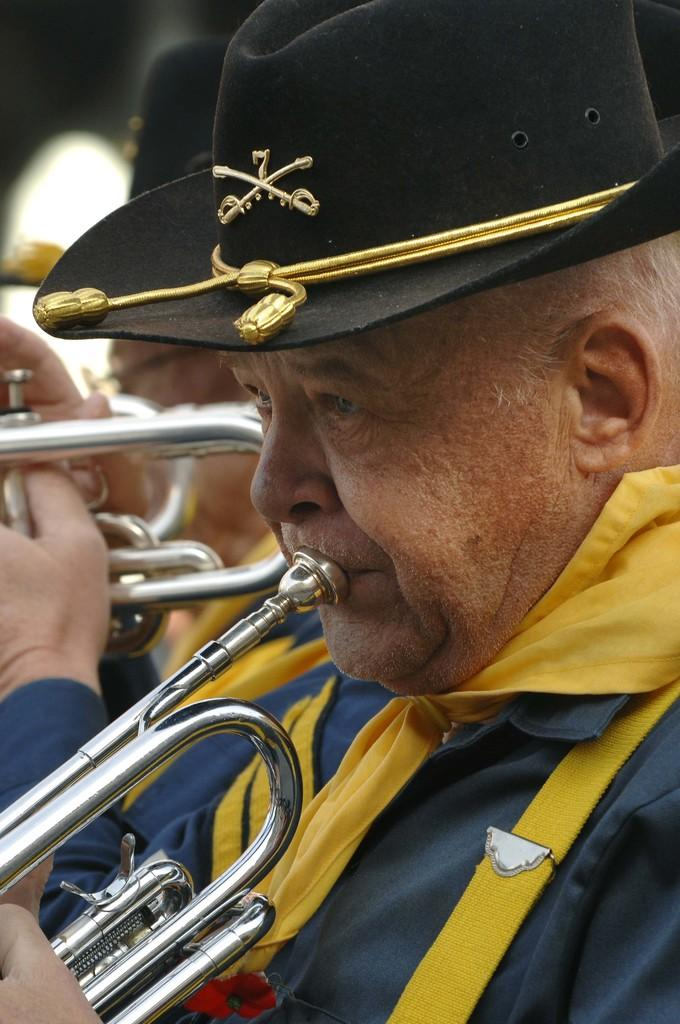Who or what is present in the image? There are people in the image. What are the people wearing on their upper bodies? The people are wearing blue color shirts. What are the people wearing on their heads? The people are wearing black color caps on their heads. What are the people doing in the image? The people are playing musical instruments. What type of powder is being used by the people in the image? There is no powder present in the image; the people are playing musical instruments. What kind of apple is being eaten by the people in the image? There is no apple present in the image; the people are playing musical instruments. 